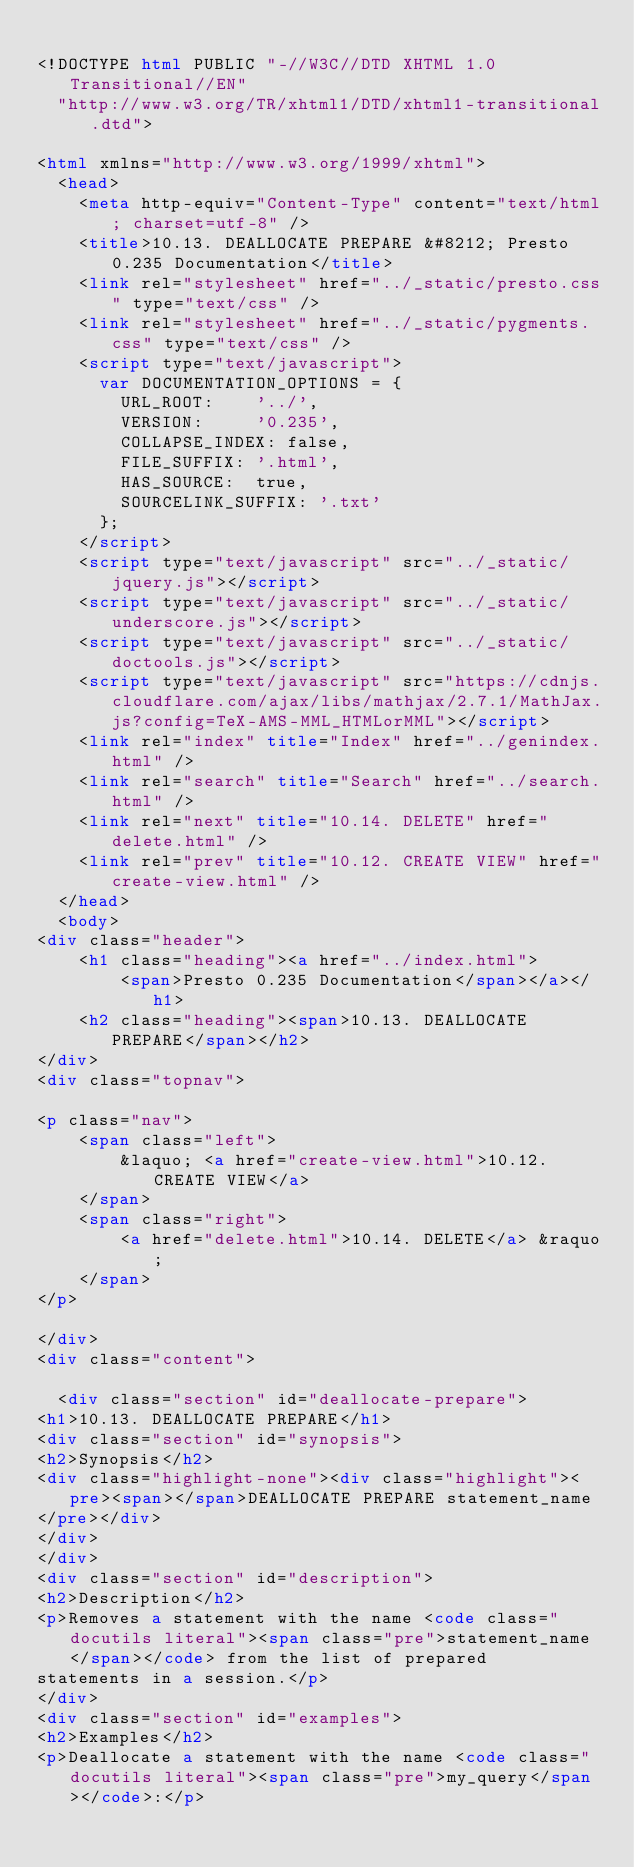Convert code to text. <code><loc_0><loc_0><loc_500><loc_500><_HTML_>
<!DOCTYPE html PUBLIC "-//W3C//DTD XHTML 1.0 Transitional//EN"
  "http://www.w3.org/TR/xhtml1/DTD/xhtml1-transitional.dtd">

<html xmlns="http://www.w3.org/1999/xhtml">
  <head>
    <meta http-equiv="Content-Type" content="text/html; charset=utf-8" />
    <title>10.13. DEALLOCATE PREPARE &#8212; Presto 0.235 Documentation</title>
    <link rel="stylesheet" href="../_static/presto.css" type="text/css" />
    <link rel="stylesheet" href="../_static/pygments.css" type="text/css" />
    <script type="text/javascript">
      var DOCUMENTATION_OPTIONS = {
        URL_ROOT:    '../',
        VERSION:     '0.235',
        COLLAPSE_INDEX: false,
        FILE_SUFFIX: '.html',
        HAS_SOURCE:  true,
        SOURCELINK_SUFFIX: '.txt'
      };
    </script>
    <script type="text/javascript" src="../_static/jquery.js"></script>
    <script type="text/javascript" src="../_static/underscore.js"></script>
    <script type="text/javascript" src="../_static/doctools.js"></script>
    <script type="text/javascript" src="https://cdnjs.cloudflare.com/ajax/libs/mathjax/2.7.1/MathJax.js?config=TeX-AMS-MML_HTMLorMML"></script>
    <link rel="index" title="Index" href="../genindex.html" />
    <link rel="search" title="Search" href="../search.html" />
    <link rel="next" title="10.14. DELETE" href="delete.html" />
    <link rel="prev" title="10.12. CREATE VIEW" href="create-view.html" /> 
  </head>
  <body>
<div class="header">
    <h1 class="heading"><a href="../index.html">
        <span>Presto 0.235 Documentation</span></a></h1>
    <h2 class="heading"><span>10.13. DEALLOCATE PREPARE</span></h2>
</div>
<div class="topnav">
    
<p class="nav">
    <span class="left">
        &laquo; <a href="create-view.html">10.12. CREATE VIEW</a>
    </span>
    <span class="right">
        <a href="delete.html">10.14. DELETE</a> &raquo;
    </span>
</p>

</div>
<div class="content">
    
  <div class="section" id="deallocate-prepare">
<h1>10.13. DEALLOCATE PREPARE</h1>
<div class="section" id="synopsis">
<h2>Synopsis</h2>
<div class="highlight-none"><div class="highlight"><pre><span></span>DEALLOCATE PREPARE statement_name
</pre></div>
</div>
</div>
<div class="section" id="description">
<h2>Description</h2>
<p>Removes a statement with the name <code class="docutils literal"><span class="pre">statement_name</span></code> from the list of prepared
statements in a session.</p>
</div>
<div class="section" id="examples">
<h2>Examples</h2>
<p>Deallocate a statement with the name <code class="docutils literal"><span class="pre">my_query</span></code>:</p></code> 